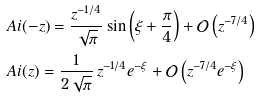Convert formula to latex. <formula><loc_0><loc_0><loc_500><loc_500>& A i ( - z ) = \frac { z ^ { - 1 / 4 } } { \sqrt { \pi } } \sin \left ( \xi + \frac { \pi } { 4 } \right ) + \mathcal { O } \left ( z ^ { - 7 / 4 } \right ) \\ & A i ( z ) = \frac { 1 } { 2 \sqrt { \pi } } \, z ^ { - 1 / 4 } e ^ { - \xi } + \mathcal { O } \left ( z ^ { - 7 / 4 } e ^ { - \xi } \right )</formula> 